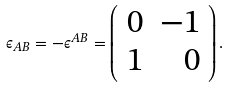Convert formula to latex. <formula><loc_0><loc_0><loc_500><loc_500>\epsilon _ { A B } = - \epsilon ^ { A B } = \left ( \begin{array} { c r c } 0 & - 1 \\ 1 & 0 \\ \end{array} \right ) .</formula> 